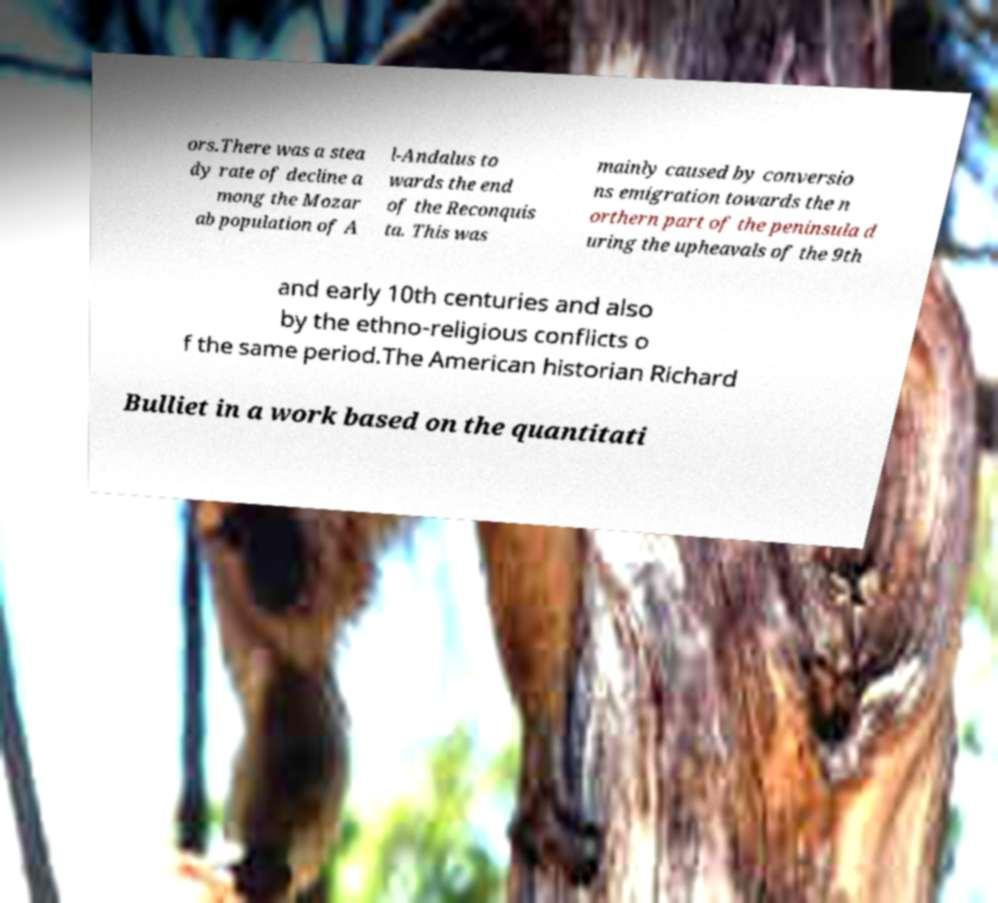For documentation purposes, I need the text within this image transcribed. Could you provide that? ors.There was a stea dy rate of decline a mong the Mozar ab population of A l-Andalus to wards the end of the Reconquis ta. This was mainly caused by conversio ns emigration towards the n orthern part of the peninsula d uring the upheavals of the 9th and early 10th centuries and also by the ethno-religious conflicts o f the same period.The American historian Richard Bulliet in a work based on the quantitati 